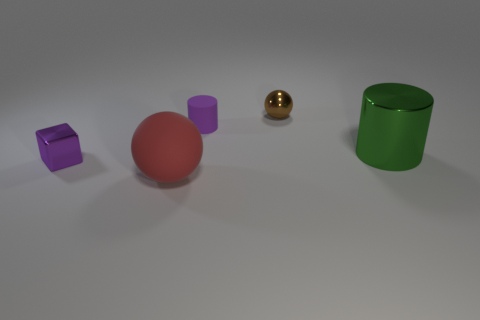Add 2 big purple shiny cubes. How many objects exist? 7 Subtract all cubes. How many objects are left? 4 Add 3 purple matte things. How many purple matte things exist? 4 Subtract 1 green cylinders. How many objects are left? 4 Subtract all small purple cylinders. Subtract all purple cubes. How many objects are left? 3 Add 2 small brown metallic objects. How many small brown metallic objects are left? 3 